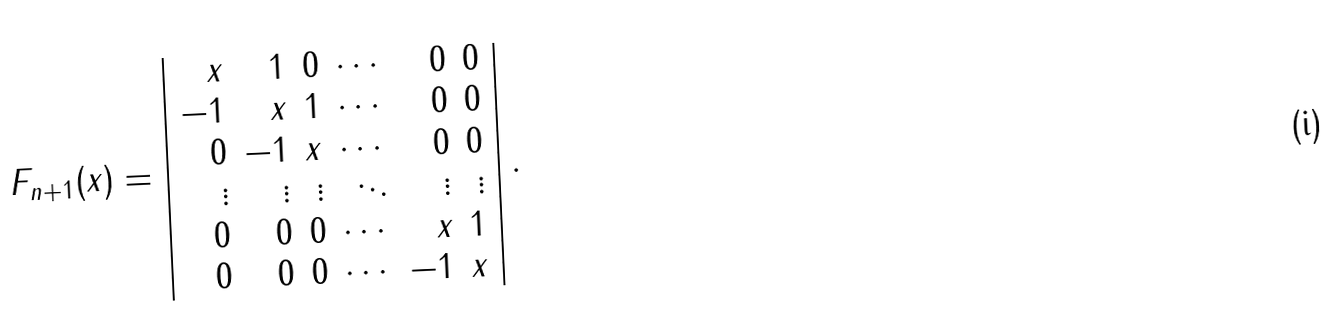Convert formula to latex. <formula><loc_0><loc_0><loc_500><loc_500>F _ { n + 1 } ( x ) = \left | \begin{array} { r r r r r r } x & 1 & 0 & \cdots & 0 & 0 \\ - 1 & x & 1 & \cdots & 0 & 0 \\ 0 & - 1 & x & \cdots & 0 & 0 \\ \vdots & \vdots & \vdots & \ddots & \vdots & \vdots \\ 0 & 0 & 0 & \cdots & x & 1 \\ 0 & 0 & 0 & \cdots & - 1 & x \end{array} \right | .</formula> 